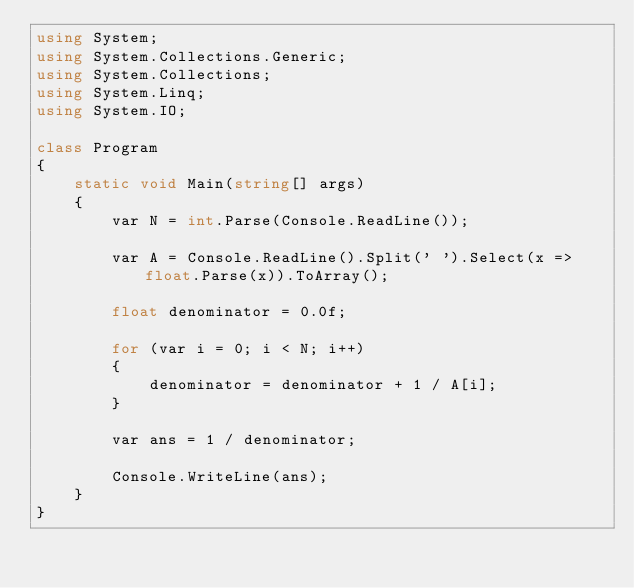Convert code to text. <code><loc_0><loc_0><loc_500><loc_500><_C#_>using System;
using System.Collections.Generic;
using System.Collections;
using System.Linq;
using System.IO;

class Program
{
    static void Main(string[] args)
    {
        var N = int.Parse(Console.ReadLine());

        var A = Console.ReadLine().Split(' ').Select(x => float.Parse(x)).ToArray();

        float denominator = 0.0f;

        for (var i = 0; i < N; i++)
        {
            denominator = denominator + 1 / A[i];
        }

        var ans = 1 / denominator;

        Console.WriteLine(ans);
    }
}
</code> 